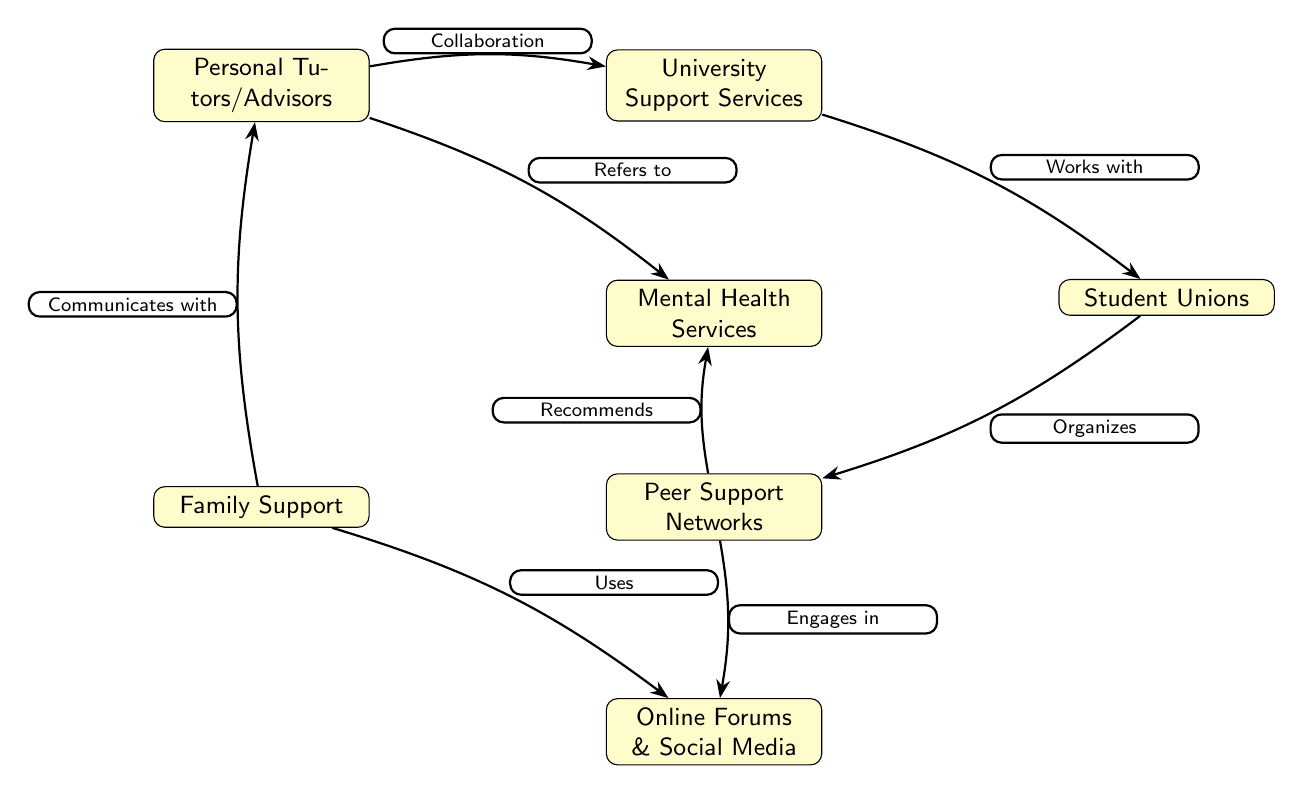What are the nodes represented in the diagram? The nodes in the diagram are Community Groups, University Support Services, Student Unions, Peer Support Networks, Family Support, Online Forums & Social Media, Personal Tutors/Advisors, and Mental Health Services.
Answer: Community Groups, University Support Services, Student Unions, Peer Support Networks, Family Support, Online Forums & Social Media, Personal Tutors/Advisors, Mental Health Services How many nodes are present in the diagram? The diagram contains 8 distinct nodes representing different support systems for Afro-Caribbean students in UK universities.
Answer: 8 What type of relationship exists between Community Groups and University Support Services? The relationship between Community Groups and University Support Services is described as "Collaboration," indicating a cooperative relationship in providing support.
Answer: Collaboration Which node is referred to by both Personal Tutors/Advisors and Peer Support Networks? Both Personal Tutors/Advisors and Peer Support Networks refer to Mental Health Services, indicating that these nodes have a shared relationship in providing mental health support.
Answer: Mental Health Services What do Family Support and Peer Support Networks have in common? Both Family Support and Peer Support Networks engage with online platforms, with Family Support using Online Forums & Social Media and Peer Support Networks engaging in them.
Answer: Online Forums & Social Media Which two nodes are involved in the mental health referral process? The nodes involved in the mental health referral process are Personal Tutors/Advisors and Peer Support Networks, as they both refer students to Mental Health Services.
Answer: Personal Tutors/Advisors, Peer Support Networks Which node is directly organized by Student Unions? The node directly organized by Student Unions is Peer Support Networks, indicating that Student Unions play a vital role in connecting students with peer support opportunities.
Answer: Peer Support Networks What is the flow of support engagement from Family Support to Personal Tutors/Advisors? The flow of support engagement begins with Family Support, which communicates with Personal Tutors/Advisors, indicating the importance of familial involvement in academic support.
Answer: Communicates with How many edges are there in the diagram? The diagram comprises 7 edges that represent the various relationships between the support nodes for Afro-Caribbean students.
Answer: 7 